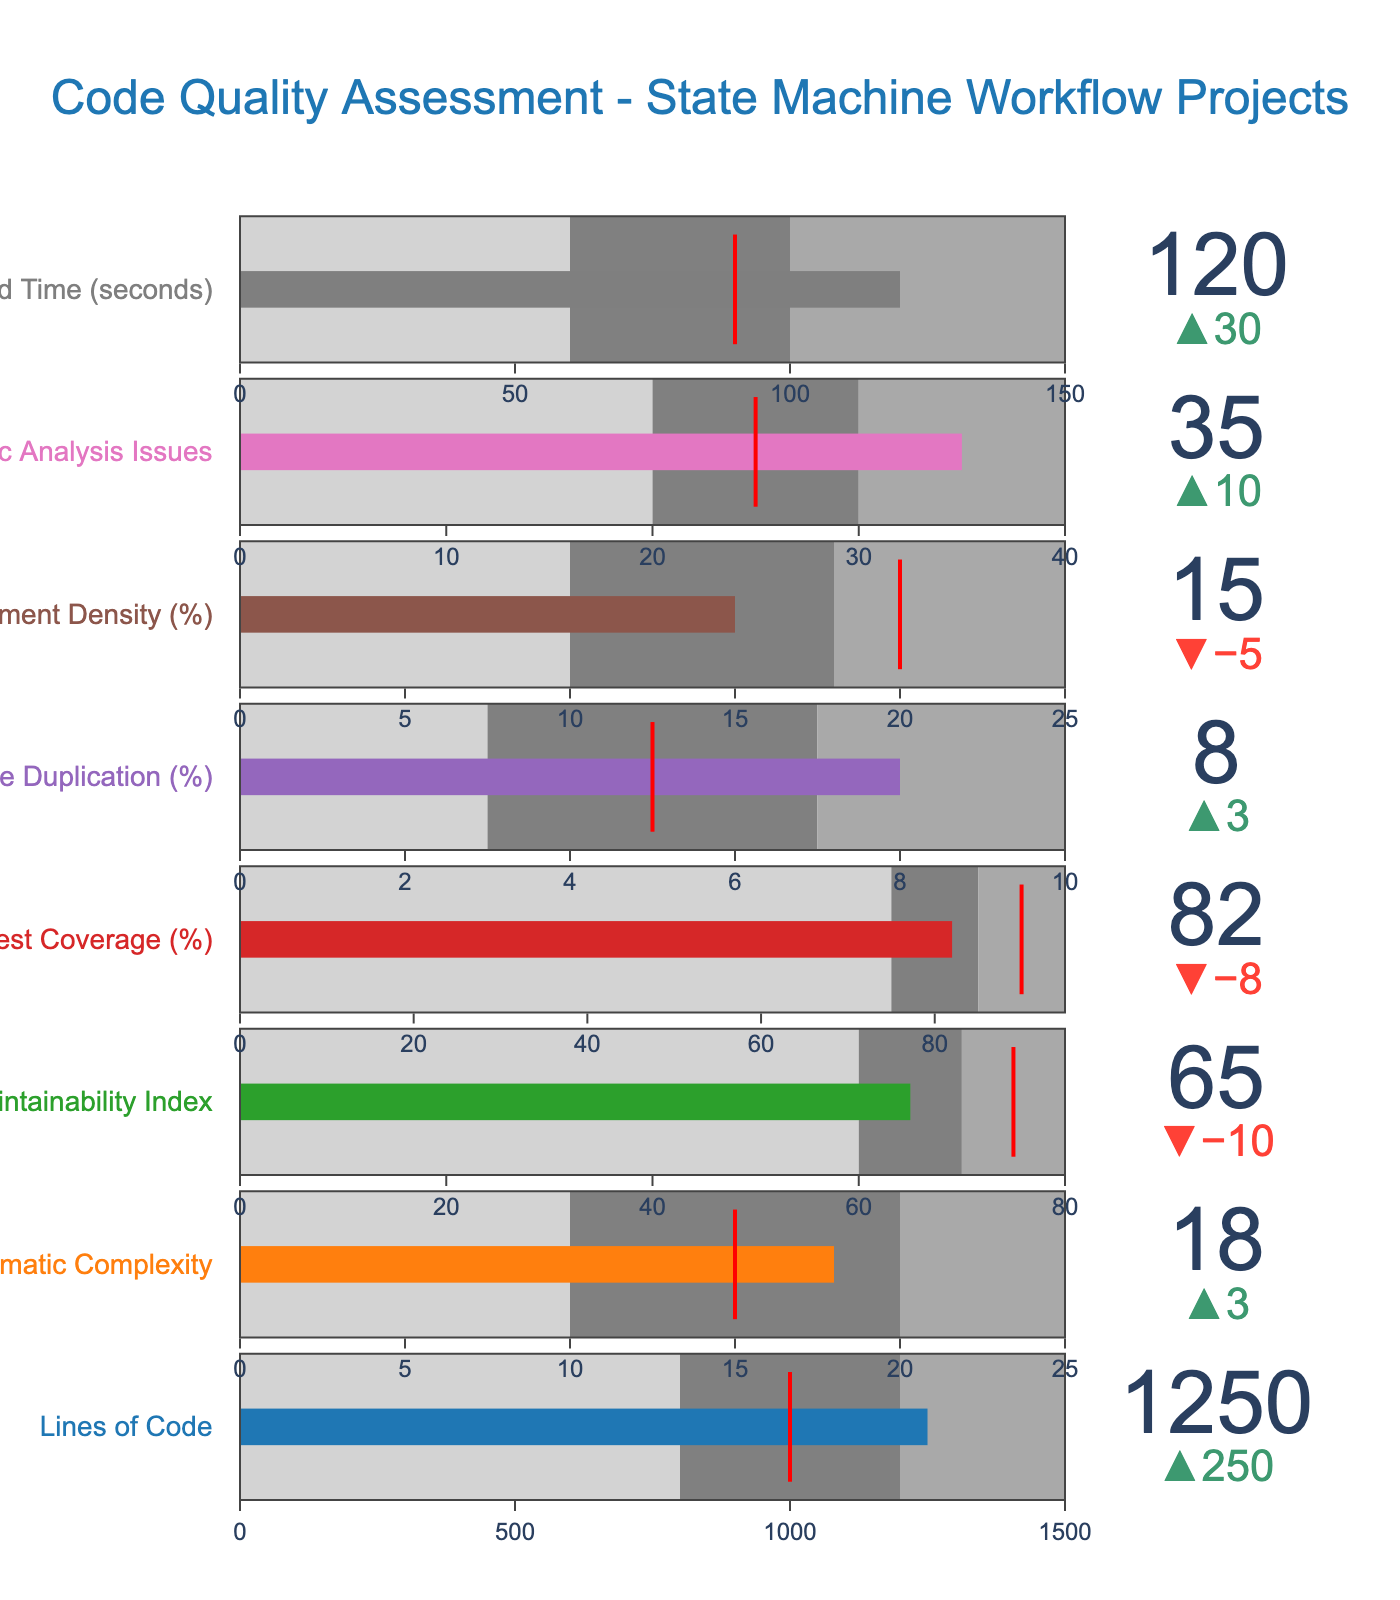Does the "Lines of Code" actual value meet the target? The actual value for "Lines of Code" is 1250, while the target is 1000. Because 1250 is greater than 1000, the actual value exceeds the target.
Answer: No What is the difference between the actual and target values for "Cyclomatic Complexity"? The actual value for "Cyclomatic Complexity" is 18, and the target is 15. The difference is calculated as 18 - 15.
Answer: 3 Which feature has the largest disparity between actual and target values? To determine the feature with the largest disparity, calculate the difference for all features: 
  - Lines of Code: 1250 - 1000 = 250
  - Cyclomatic Complexity: 18 - 15 = 3
  - Maintainability Index: 75 - 65 = 10
  - Test Coverage: 90 - 82 = 8
  - Code Duplication: 8 - 5 = 3
  - Comment Density: 20 - 15 = 5
  - Static Analysis Issues: 35 - 25 = 10
  - Build Time: 120 - 90 = 30
  
The largest difference is for "Lines of Code," with a disparity of 250.
Answer: Lines of Code In which range does the actual "Maintainability Index" fall? The actual "Maintainability Index" value is 65. The defined ranges are:
  - Range 1: 0-60
  - Range 2: 60-70
  - Range 3: 70-80
Since 65 falls within Range 2 (60-70), the "Maintainability Index" lies in the second range.
Answer: Range 2 Which feature is closest to its target value? To determine the closest feature to its target, calculate the absolute differences:
  - Lines of Code: 250
  - Cyclomatic Complexity: 3
  - Maintainability Index: 10
  - Test Coverage: 8
  - Code Duplication: 3
  - Comment Density: 5
  - Static Analysis Issues: 10
  - Build Time: 30
  
The smallest difference is 3, for both "Cyclomatic Complexity" and "Code Duplication."
Answer: Cyclomatic Complexity and Code Duplication What is the largest allowed value in "Range 3" for "Build Time"? The largest value in "Range 3" for "Build Time" is given directly as 150.
Answer: 150 Is the "Test Coverage" actually within the expected range (target)? The actual "Test Coverage" is 82, and the target is 90. It is not within the range since the target is higher and not met. The acceptable range is between 75 and 95.
Answer: No What is the difference between the highest and lowest "Range 1" values across all features? "Range 1" values are:
  - Lines of Code: 800
  - Cyclomatic Complexity: 10
  - Maintainability Index: 60
  - Test Coverage: 75
  - Code Duplication: 3
  - Comment Density: 10
  - Static Analysis Issues: 20
  - Build Time: 60
  
The highest "Range 1" value is 800 (Lines of Code), and the lowest is 3 (Code Duplication). The difference is 800 - 3.
Answer: 797 Which feature is furthest from being optimal (closest to the edge of Range 3)? To determine this, compare the actual values with Range 3's upper boundary for each feature:
  - Lines of Code: 1250 vs. 1500 (250 away)
  - Cyclomatic Complexity: 18 vs. 25 (7 away)
  - Maintainability Index: 65 vs. 80 (15 away)
  - Test Coverage: 82 vs. 95 (13 away)
  - Code Duplication: 8 vs. 10 (2 away)
  - Comment Density: 15 vs. 25 (10 away)
  - Static Analysis Issues: 35 vs. 40 (5 away)
  - Build Time: 120 vs. 150 (30 away)
  
The furthest feature is "Lines of Code," being 250 units from the edge.
Answer: Lines of Code 